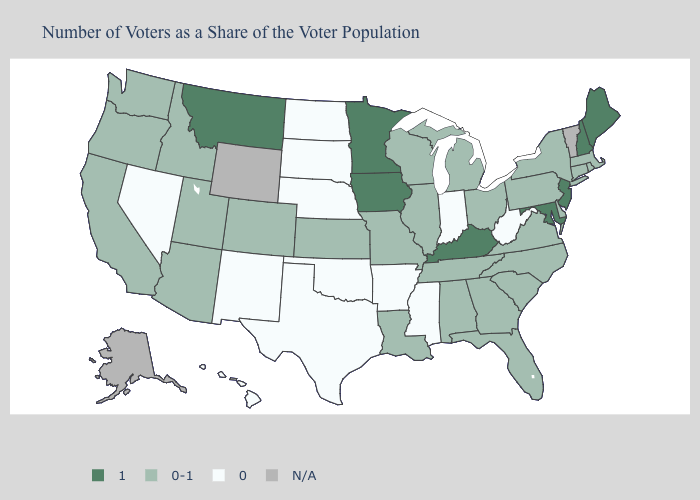Which states have the lowest value in the USA?
Answer briefly. Arkansas, Hawaii, Indiana, Mississippi, Nebraska, Nevada, New Mexico, North Dakota, Oklahoma, South Dakota, Texas, West Virginia. Name the states that have a value in the range 1?
Concise answer only. Iowa, Kentucky, Maine, Maryland, Minnesota, Montana, New Hampshire, New Jersey. What is the value of Kansas?
Be succinct. 0-1. What is the value of Massachusetts?
Give a very brief answer. 0-1. What is the value of Delaware?
Concise answer only. 0-1. Which states have the lowest value in the USA?
Keep it brief. Arkansas, Hawaii, Indiana, Mississippi, Nebraska, Nevada, New Mexico, North Dakota, Oklahoma, South Dakota, Texas, West Virginia. Among the states that border Connecticut , which have the highest value?
Be succinct. Massachusetts, New York, Rhode Island. Which states have the highest value in the USA?
Concise answer only. Iowa, Kentucky, Maine, Maryland, Minnesota, Montana, New Hampshire, New Jersey. What is the lowest value in the MidWest?
Short answer required. 0. What is the lowest value in the USA?
Concise answer only. 0. Does the map have missing data?
Give a very brief answer. Yes. What is the value of Illinois?
Short answer required. 0-1. Name the states that have a value in the range 0?
Be succinct. Arkansas, Hawaii, Indiana, Mississippi, Nebraska, Nevada, New Mexico, North Dakota, Oklahoma, South Dakota, Texas, West Virginia. Does New York have the highest value in the Northeast?
Write a very short answer. No. 